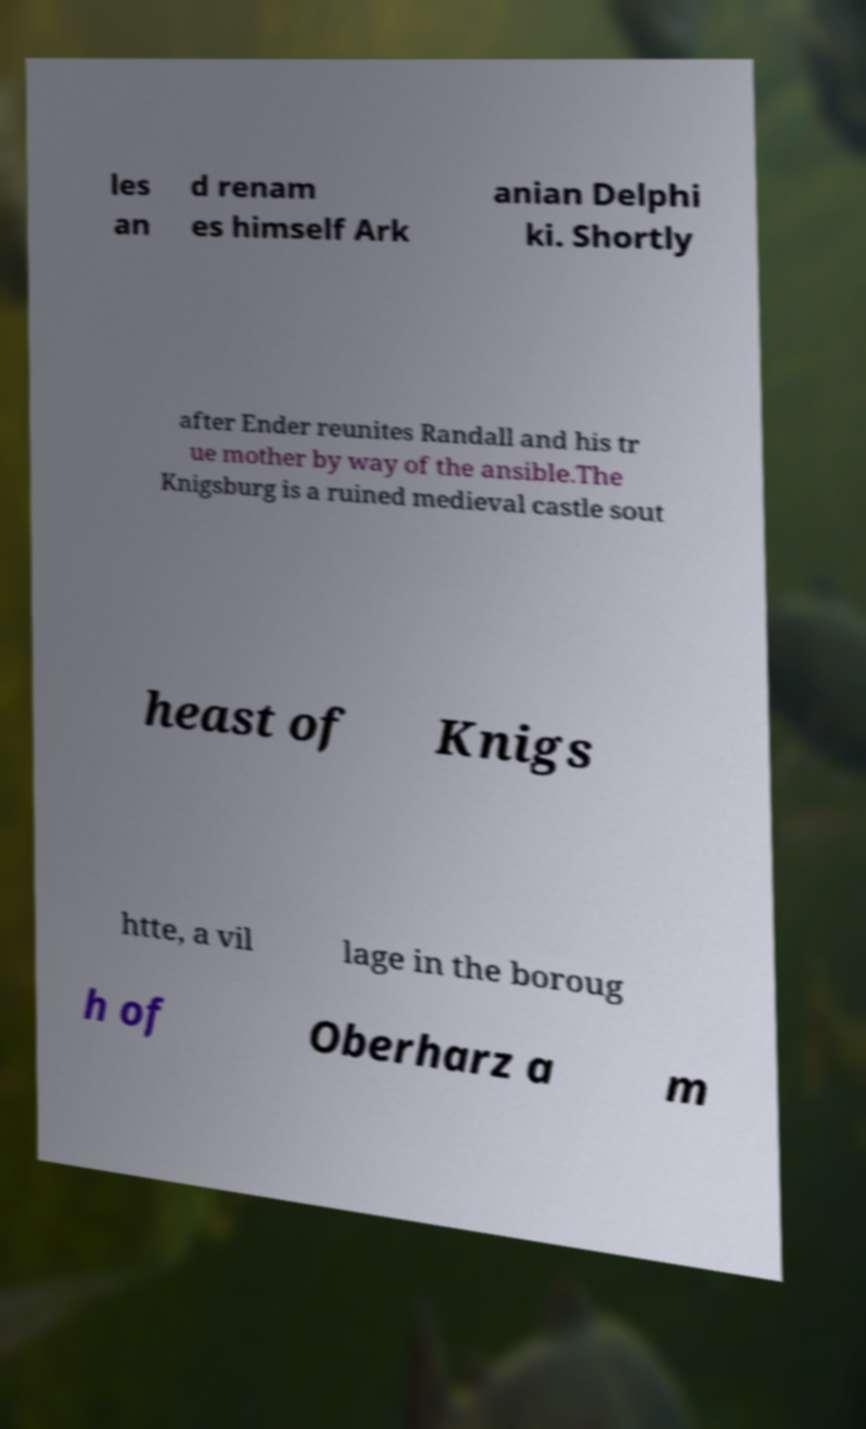Can you accurately transcribe the text from the provided image for me? les an d renam es himself Ark anian Delphi ki. Shortly after Ender reunites Randall and his tr ue mother by way of the ansible.The Knigsburg is a ruined medieval castle sout heast of Knigs htte, a vil lage in the boroug h of Oberharz a m 